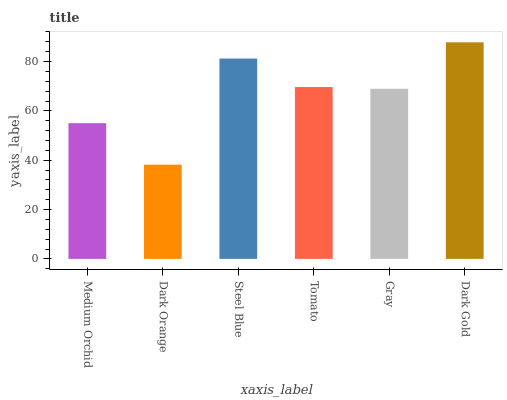Is Steel Blue the minimum?
Answer yes or no. No. Is Steel Blue the maximum?
Answer yes or no. No. Is Steel Blue greater than Dark Orange?
Answer yes or no. Yes. Is Dark Orange less than Steel Blue?
Answer yes or no. Yes. Is Dark Orange greater than Steel Blue?
Answer yes or no. No. Is Steel Blue less than Dark Orange?
Answer yes or no. No. Is Tomato the high median?
Answer yes or no. Yes. Is Gray the low median?
Answer yes or no. Yes. Is Medium Orchid the high median?
Answer yes or no. No. Is Steel Blue the low median?
Answer yes or no. No. 